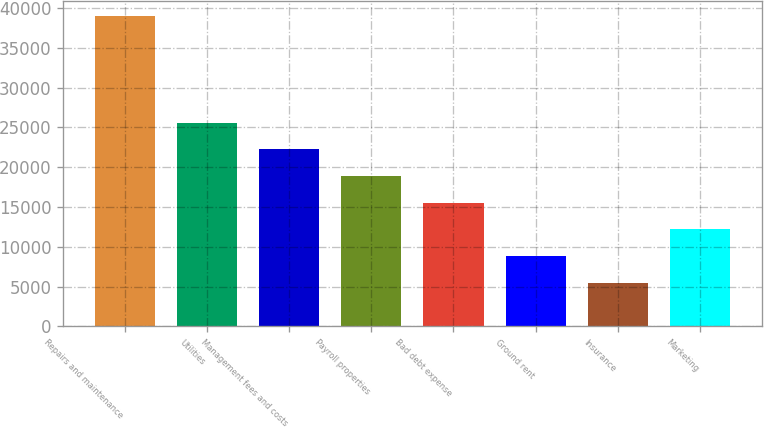Convert chart to OTSL. <chart><loc_0><loc_0><loc_500><loc_500><bar_chart><fcel>Repairs and maintenance<fcel>Utilities<fcel>Management fees and costs<fcel>Payroll properties<fcel>Bad debt expense<fcel>Ground rent<fcel>Insurance<fcel>Marketing<nl><fcel>38969<fcel>25585.4<fcel>22239.5<fcel>18893.6<fcel>15547.7<fcel>8855.9<fcel>5510<fcel>12201.8<nl></chart> 